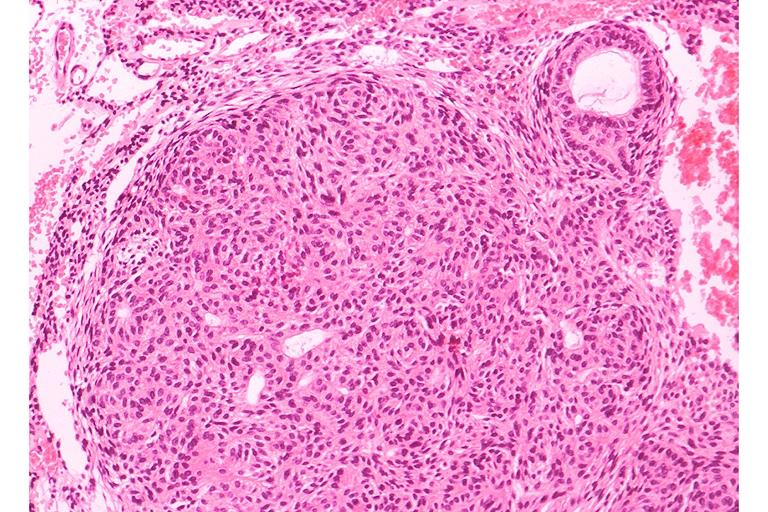what is present?
Answer the question using a single word or phrase. Oral 